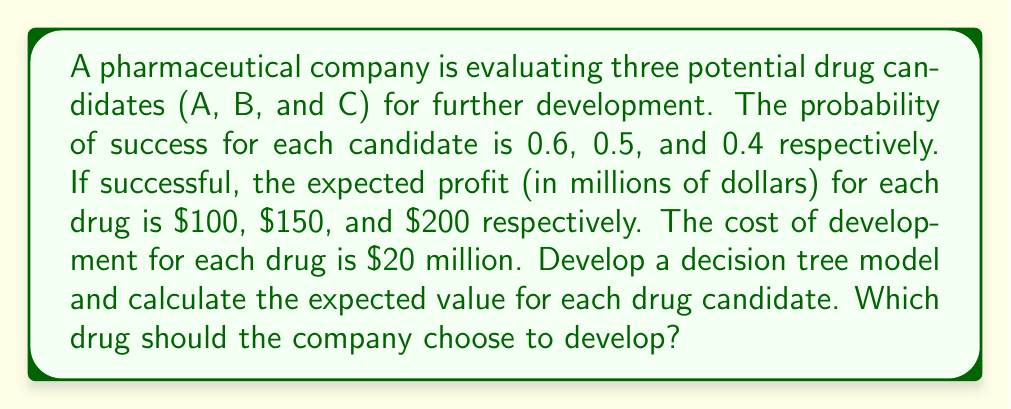Provide a solution to this math problem. Let's develop a decision tree model and calculate the expected value for each drug candidate:

1. For each drug candidate, we have two possible outcomes: success or failure.

2. Let's calculate the expected value (EV) for each drug:

   Drug A:
   $$EV(A) = (0.6 \times 100) + (0.4 \times 0) - 20 = 40$$

   Drug B:
   $$EV(B) = (0.5 \times 150) + (0.5 \times 0) - 20 = 55$$

   Drug C:
   $$EV(C) = (0.4 \times 200) + (0.6 \times 0) - 20 = 60$$

3. The decision tree can be represented as follows:

[asy]
import geometry;

real nodeSize = 3;
pen decisionColor = rgb(0,0.5,0);
pen chanceColor = rgb(0,0,1);
pen textColor = rgb(0,0,0);

void drawNode(pair p, bool isDecision) {
    if (isDecision) {
        fill(p, polygon(nodeSize){(-1,0),(0,1),(1,0),(0,-1)}, decisionColor);
    } else {
        fill(p, circle(nodeSize), chanceColor);
    }
}

drawNode((0,0), true);

drawNode((-20,20), false);
drawNode((0,20), false);
drawNode((20,20), false);

draw((0,0)--(-20,20));
draw((0,0)--(0,20));
draw((0,0)--(20,20));

label("A", (-20,20), N);
label("B", (0,20), N);
label("C", (20,20), N);

draw((-25,30)--(-15,30));
draw((-5,30)--(5,30));
draw((15,30)--(25,30));

label("S", (-27,30), W);
label("F", (-13,30), E);
label("S", (-7,30), W);
label("F", (7,30), E);
label("S", (13,30), W);
label("F", (27,30), E);

label("EV = 40", (-20,10), E);
label("EV = 55", (0,10), E);
label("EV = 60", (20,10), E);

label("Choose Drug", (0,-5), S);
[/asy]

4. Comparing the expected values:
   Drug A: $40 million
   Drug B: $55 million
   Drug C: $60 million

5. The company should choose the drug candidate with the highest expected value.
Answer: The company should choose to develop Drug C, which has the highest expected value of $60 million. 